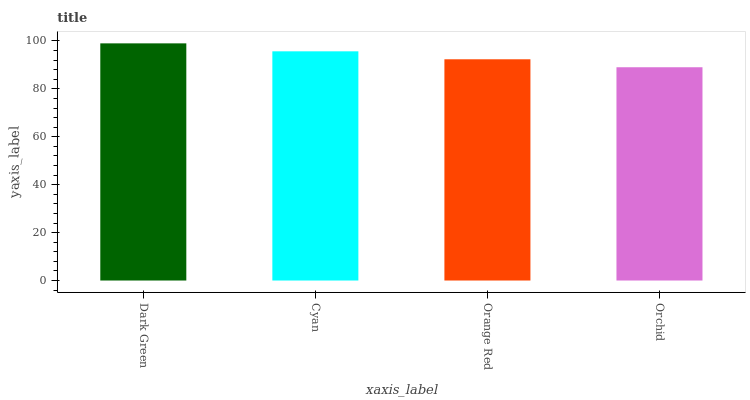Is Orchid the minimum?
Answer yes or no. Yes. Is Dark Green the maximum?
Answer yes or no. Yes. Is Cyan the minimum?
Answer yes or no. No. Is Cyan the maximum?
Answer yes or no. No. Is Dark Green greater than Cyan?
Answer yes or no. Yes. Is Cyan less than Dark Green?
Answer yes or no. Yes. Is Cyan greater than Dark Green?
Answer yes or no. No. Is Dark Green less than Cyan?
Answer yes or no. No. Is Cyan the high median?
Answer yes or no. Yes. Is Orange Red the low median?
Answer yes or no. Yes. Is Dark Green the high median?
Answer yes or no. No. Is Cyan the low median?
Answer yes or no. No. 